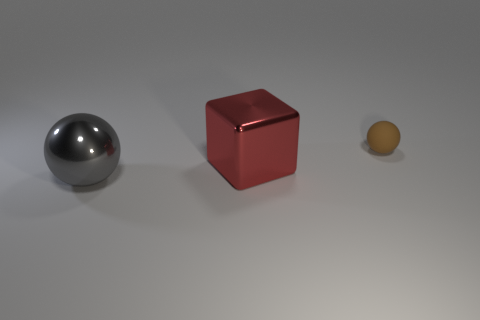Are there any other things that have the same material as the tiny brown ball?
Keep it short and to the point. No. Is the number of large red metal blocks greater than the number of shiny objects?
Ensure brevity in your answer.  No. What number of other things are there of the same color as the tiny matte sphere?
Ensure brevity in your answer.  0. What number of big shiny things are to the right of the big gray metallic object and to the left of the red metal cube?
Offer a very short reply. 0. Is there anything else that is the same size as the matte thing?
Keep it short and to the point. No. Are there more things in front of the big shiny block than small brown matte objects that are in front of the tiny rubber sphere?
Your response must be concise. Yes. There is a sphere behind the big red shiny thing; what material is it?
Offer a very short reply. Rubber. Do the matte object and the big metallic object that is on the left side of the large red shiny thing have the same shape?
Your response must be concise. Yes. There is a large object that is on the right side of the object that is in front of the big red metal object; how many large red metal things are on the right side of it?
Offer a terse response. 0. What is the color of the other thing that is the same shape as the gray thing?
Offer a very short reply. Brown. 